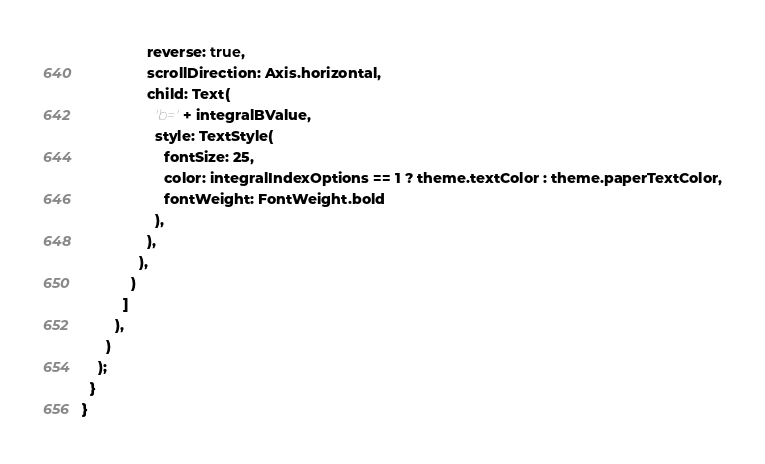<code> <loc_0><loc_0><loc_500><loc_500><_Dart_>                reverse: true,
                scrollDirection: Axis.horizontal,
                child: Text(
                  'b=' + integralBValue,
                  style: TextStyle(
                    fontSize: 25,
                    color: integralIndexOptions == 1 ? theme.textColor : theme.paperTextColor,
                    fontWeight: FontWeight.bold
                  ),
                ),
              ),
            )
          ]
        ),
      )
    );
  }
}</code> 